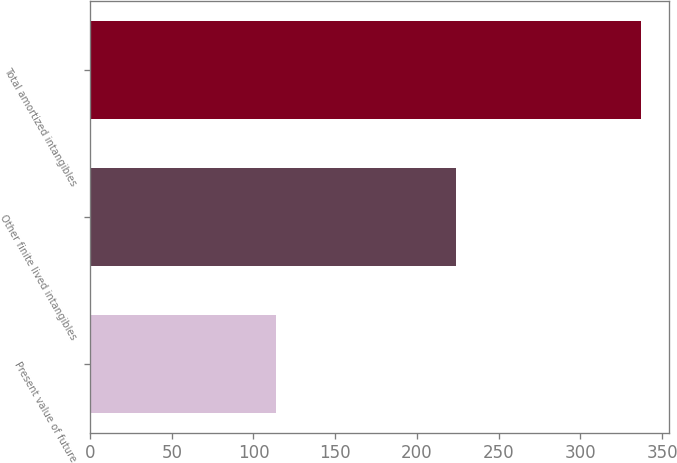<chart> <loc_0><loc_0><loc_500><loc_500><bar_chart><fcel>Present value of future<fcel>Other finite lived intangibles<fcel>Total amortized intangibles<nl><fcel>113.6<fcel>223.6<fcel>337.2<nl></chart> 